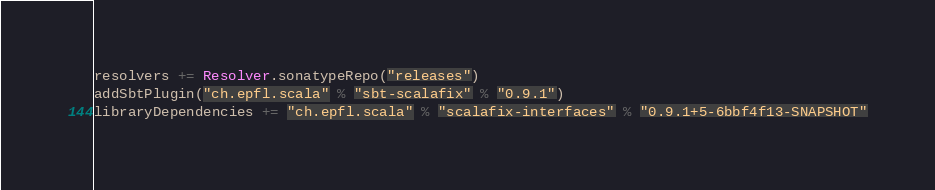<code> <loc_0><loc_0><loc_500><loc_500><_Scala_>resolvers += Resolver.sonatypeRepo("releases")
addSbtPlugin("ch.epfl.scala" % "sbt-scalafix" % "0.9.1")
libraryDependencies += "ch.epfl.scala" % "scalafix-interfaces" % "0.9.1+5-6bbf4f13-SNAPSHOT"
</code> 